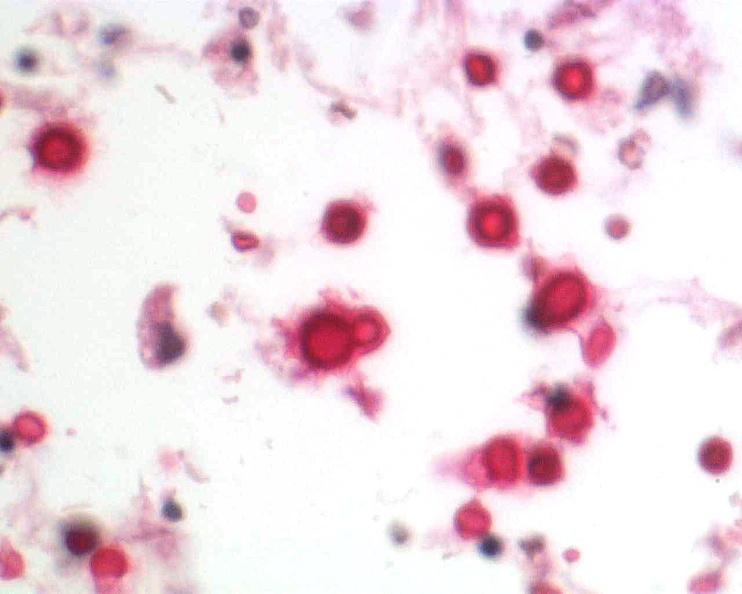does this image show brain, cryptococcal meningitis?
Answer the question using a single word or phrase. Yes 